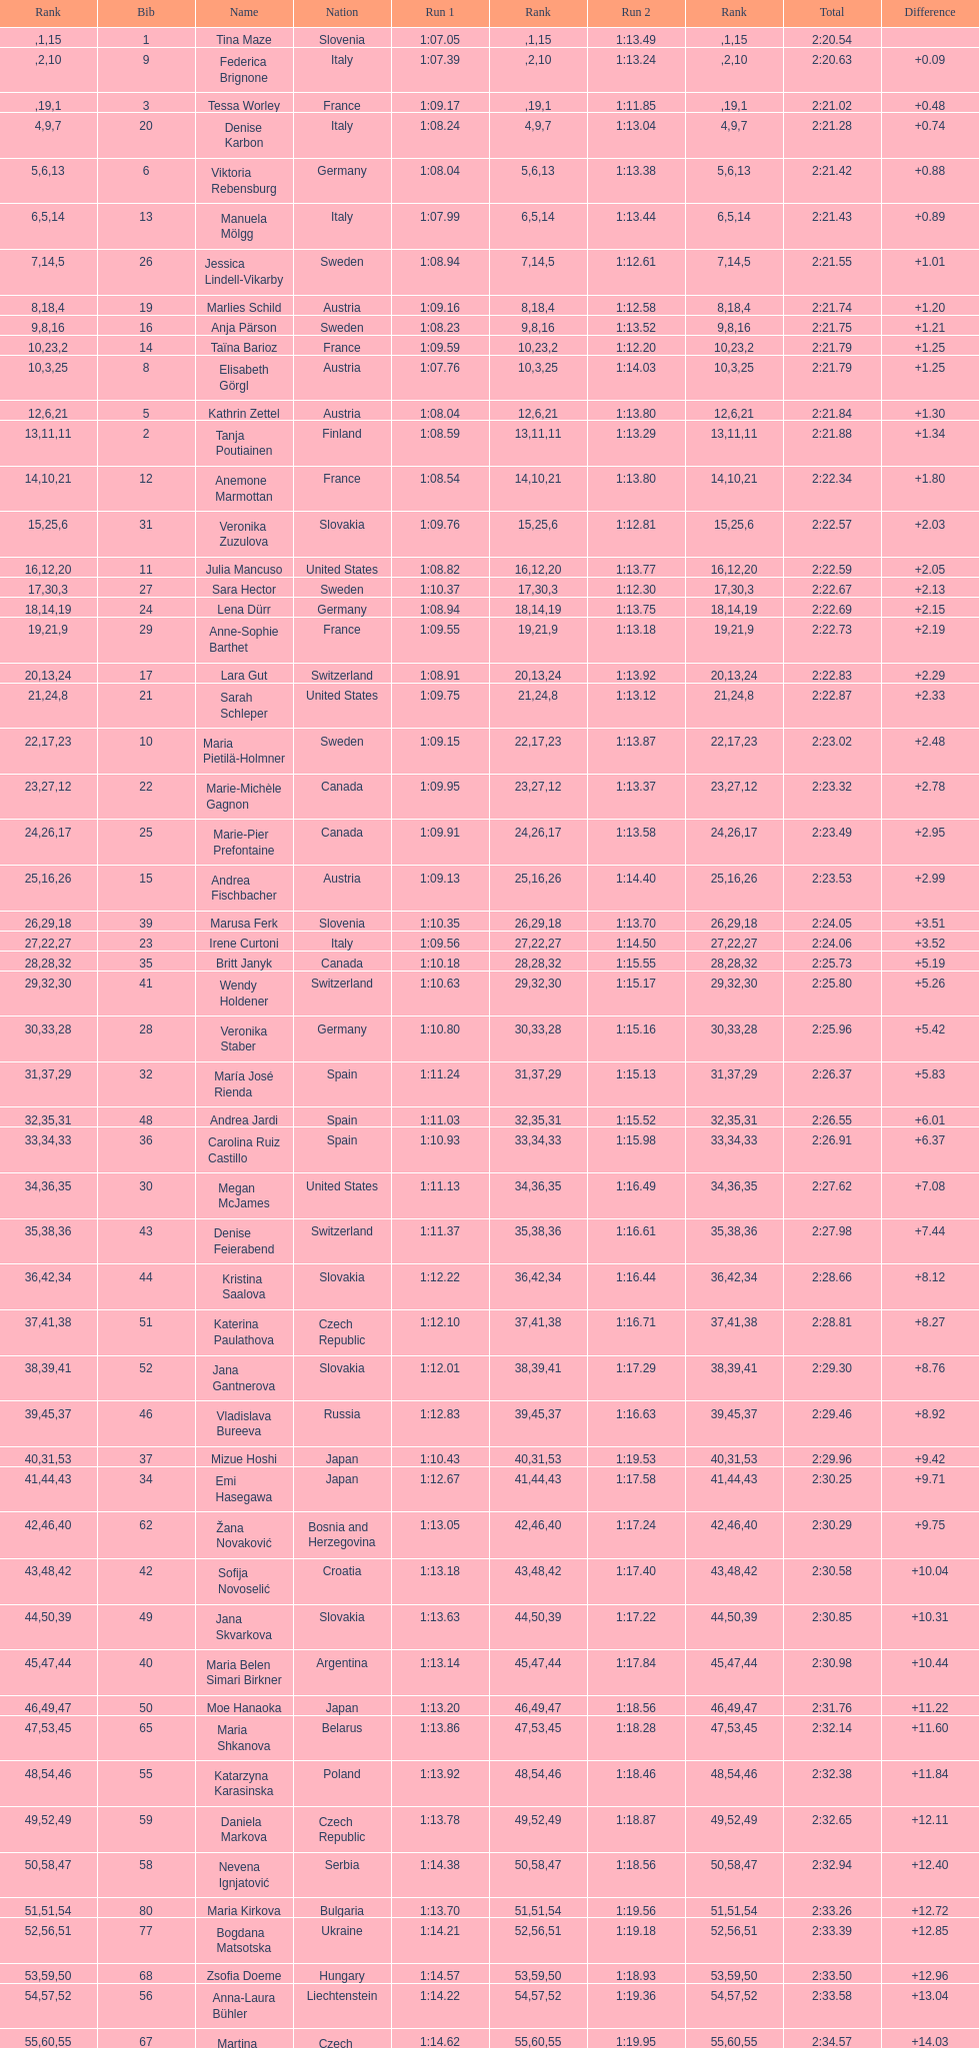Can you parse all the data within this table? {'header': ['Rank', 'Bib', 'Name', 'Nation', 'Run 1', 'Rank', 'Run 2', 'Rank', 'Total', 'Difference'], 'rows': [['', '1', 'Tina Maze', 'Slovenia', '1:07.05', '1', '1:13.49', '15', '2:20.54', ''], ['', '9', 'Federica Brignone', 'Italy', '1:07.39', '2', '1:13.24', '10', '2:20.63', '+0.09'], ['', '3', 'Tessa Worley', 'France', '1:09.17', '19', '1:11.85', '1', '2:21.02', '+0.48'], ['4', '20', 'Denise Karbon', 'Italy', '1:08.24', '9', '1:13.04', '7', '2:21.28', '+0.74'], ['5', '6', 'Viktoria Rebensburg', 'Germany', '1:08.04', '6', '1:13.38', '13', '2:21.42', '+0.88'], ['6', '13', 'Manuela Mölgg', 'Italy', '1:07.99', '5', '1:13.44', '14', '2:21.43', '+0.89'], ['7', '26', 'Jessica Lindell-Vikarby', 'Sweden', '1:08.94', '14', '1:12.61', '5', '2:21.55', '+1.01'], ['8', '19', 'Marlies Schild', 'Austria', '1:09.16', '18', '1:12.58', '4', '2:21.74', '+1.20'], ['9', '16', 'Anja Pärson', 'Sweden', '1:08.23', '8', '1:13.52', '16', '2:21.75', '+1.21'], ['10', '14', 'Taïna Barioz', 'France', '1:09.59', '23', '1:12.20', '2', '2:21.79', '+1.25'], ['10', '8', 'Elisabeth Görgl', 'Austria', '1:07.76', '3', '1:14.03', '25', '2:21.79', '+1.25'], ['12', '5', 'Kathrin Zettel', 'Austria', '1:08.04', '6', '1:13.80', '21', '2:21.84', '+1.30'], ['13', '2', 'Tanja Poutiainen', 'Finland', '1:08.59', '11', '1:13.29', '11', '2:21.88', '+1.34'], ['14', '12', 'Anemone Marmottan', 'France', '1:08.54', '10', '1:13.80', '21', '2:22.34', '+1.80'], ['15', '31', 'Veronika Zuzulova', 'Slovakia', '1:09.76', '25', '1:12.81', '6', '2:22.57', '+2.03'], ['16', '11', 'Julia Mancuso', 'United States', '1:08.82', '12', '1:13.77', '20', '2:22.59', '+2.05'], ['17', '27', 'Sara Hector', 'Sweden', '1:10.37', '30', '1:12.30', '3', '2:22.67', '+2.13'], ['18', '24', 'Lena Dürr', 'Germany', '1:08.94', '14', '1:13.75', '19', '2:22.69', '+2.15'], ['19', '29', 'Anne-Sophie Barthet', 'France', '1:09.55', '21', '1:13.18', '9', '2:22.73', '+2.19'], ['20', '17', 'Lara Gut', 'Switzerland', '1:08.91', '13', '1:13.92', '24', '2:22.83', '+2.29'], ['21', '21', 'Sarah Schleper', 'United States', '1:09.75', '24', '1:13.12', '8', '2:22.87', '+2.33'], ['22', '10', 'Maria Pietilä-Holmner', 'Sweden', '1:09.15', '17', '1:13.87', '23', '2:23.02', '+2.48'], ['23', '22', 'Marie-Michèle Gagnon', 'Canada', '1:09.95', '27', '1:13.37', '12', '2:23.32', '+2.78'], ['24', '25', 'Marie-Pier Prefontaine', 'Canada', '1:09.91', '26', '1:13.58', '17', '2:23.49', '+2.95'], ['25', '15', 'Andrea Fischbacher', 'Austria', '1:09.13', '16', '1:14.40', '26', '2:23.53', '+2.99'], ['26', '39', 'Marusa Ferk', 'Slovenia', '1:10.35', '29', '1:13.70', '18', '2:24.05', '+3.51'], ['27', '23', 'Irene Curtoni', 'Italy', '1:09.56', '22', '1:14.50', '27', '2:24.06', '+3.52'], ['28', '35', 'Britt Janyk', 'Canada', '1:10.18', '28', '1:15.55', '32', '2:25.73', '+5.19'], ['29', '41', 'Wendy Holdener', 'Switzerland', '1:10.63', '32', '1:15.17', '30', '2:25.80', '+5.26'], ['30', '28', 'Veronika Staber', 'Germany', '1:10.80', '33', '1:15.16', '28', '2:25.96', '+5.42'], ['31', '32', 'María José Rienda', 'Spain', '1:11.24', '37', '1:15.13', '29', '2:26.37', '+5.83'], ['32', '48', 'Andrea Jardi', 'Spain', '1:11.03', '35', '1:15.52', '31', '2:26.55', '+6.01'], ['33', '36', 'Carolina Ruiz Castillo', 'Spain', '1:10.93', '34', '1:15.98', '33', '2:26.91', '+6.37'], ['34', '30', 'Megan McJames', 'United States', '1:11.13', '36', '1:16.49', '35', '2:27.62', '+7.08'], ['35', '43', 'Denise Feierabend', 'Switzerland', '1:11.37', '38', '1:16.61', '36', '2:27.98', '+7.44'], ['36', '44', 'Kristina Saalova', 'Slovakia', '1:12.22', '42', '1:16.44', '34', '2:28.66', '+8.12'], ['37', '51', 'Katerina Paulathova', 'Czech Republic', '1:12.10', '41', '1:16.71', '38', '2:28.81', '+8.27'], ['38', '52', 'Jana Gantnerova', 'Slovakia', '1:12.01', '39', '1:17.29', '41', '2:29.30', '+8.76'], ['39', '46', 'Vladislava Bureeva', 'Russia', '1:12.83', '45', '1:16.63', '37', '2:29.46', '+8.92'], ['40', '37', 'Mizue Hoshi', 'Japan', '1:10.43', '31', '1:19.53', '53', '2:29.96', '+9.42'], ['41', '34', 'Emi Hasegawa', 'Japan', '1:12.67', '44', '1:17.58', '43', '2:30.25', '+9.71'], ['42', '62', 'Žana Novaković', 'Bosnia and Herzegovina', '1:13.05', '46', '1:17.24', '40', '2:30.29', '+9.75'], ['43', '42', 'Sofija Novoselić', 'Croatia', '1:13.18', '48', '1:17.40', '42', '2:30.58', '+10.04'], ['44', '49', 'Jana Skvarkova', 'Slovakia', '1:13.63', '50', '1:17.22', '39', '2:30.85', '+10.31'], ['45', '40', 'Maria Belen Simari Birkner', 'Argentina', '1:13.14', '47', '1:17.84', '44', '2:30.98', '+10.44'], ['46', '50', 'Moe Hanaoka', 'Japan', '1:13.20', '49', '1:18.56', '47', '2:31.76', '+11.22'], ['47', '65', 'Maria Shkanova', 'Belarus', '1:13.86', '53', '1:18.28', '45', '2:32.14', '+11.60'], ['48', '55', 'Katarzyna Karasinska', 'Poland', '1:13.92', '54', '1:18.46', '46', '2:32.38', '+11.84'], ['49', '59', 'Daniela Markova', 'Czech Republic', '1:13.78', '52', '1:18.87', '49', '2:32.65', '+12.11'], ['50', '58', 'Nevena Ignjatović', 'Serbia', '1:14.38', '58', '1:18.56', '47', '2:32.94', '+12.40'], ['51', '80', 'Maria Kirkova', 'Bulgaria', '1:13.70', '51', '1:19.56', '54', '2:33.26', '+12.72'], ['52', '77', 'Bogdana Matsotska', 'Ukraine', '1:14.21', '56', '1:19.18', '51', '2:33.39', '+12.85'], ['53', '68', 'Zsofia Doeme', 'Hungary', '1:14.57', '59', '1:18.93', '50', '2:33.50', '+12.96'], ['54', '56', 'Anna-Laura Bühler', 'Liechtenstein', '1:14.22', '57', '1:19.36', '52', '2:33.58', '+13.04'], ['55', '67', 'Martina Dubovska', 'Czech Republic', '1:14.62', '60', '1:19.95', '55', '2:34.57', '+14.03'], ['', '7', 'Kathrin Hölzl', 'Germany', '1:09.41', '20', 'DNS', '', '', ''], ['', '4', 'Maria Riesch', 'Germany', '1:07.86', '4', 'DNF', '', '', ''], ['', '38', 'Rebecca Bühler', 'Liechtenstein', '1:12.03', '40', 'DNF', '', '', ''], ['', '47', 'Vanessa Schädler', 'Liechtenstein', '1:12.47', '43', 'DNF', '', '', ''], ['', '69', 'Iris Gudmundsdottir', 'Iceland', '1:13.93', '55', 'DNF', '', '', ''], ['', '45', 'Tea Palić', 'Croatia', '1:14.73', '61', 'DNQ', '', '', ''], ['', '74', 'Macarena Simari Birkner', 'Argentina', '1:15.18', '62', 'DNQ', '', '', ''], ['', '72', 'Lavinia Chrystal', 'Australia', '1:15.35', '63', 'DNQ', '', '', ''], ['', '81', 'Lelde Gasuna', 'Latvia', '1:15.37', '64', 'DNQ', '', '', ''], ['', '64', 'Aleksandra Klus', 'Poland', '1:15.41', '65', 'DNQ', '', '', ''], ['', '78', 'Nino Tsiklauri', 'Georgia', '1:15.54', '66', 'DNQ', '', '', ''], ['', '66', 'Sarah Jarvis', 'New Zealand', '1:15.94', '67', 'DNQ', '', '', ''], ['', '61', 'Anna Berecz', 'Hungary', '1:15.95', '68', 'DNQ', '', '', ''], ['', '83', 'Sandra-Elena Narea', 'Romania', '1:16.67', '69', 'DNQ', '', '', ''], ['', '85', 'Iulia Petruta Craciun', 'Romania', '1:16.80', '70', 'DNQ', '', '', ''], ['', '82', 'Isabel van Buynder', 'Belgium', '1:17.06', '71', 'DNQ', '', '', ''], ['', '97', 'Liene Fimbauere', 'Latvia', '1:17.83', '72', 'DNQ', '', '', ''], ['', '86', 'Kristina Krone', 'Puerto Rico', '1:17.93', '73', 'DNQ', '', '', ''], ['', '88', 'Nicole Valcareggi', 'Greece', '1:18.19', '74', 'DNQ', '', '', ''], ['', '100', 'Sophie Fjellvang-Sølling', 'Denmark', '1:18.37', '75', 'DNQ', '', '', ''], ['', '95', 'Ornella Oettl Reyes', 'Peru', '1:18.61', '76', 'DNQ', '', '', ''], ['', '73', 'Xia Lina', 'China', '1:19.12', '77', 'DNQ', '', '', ''], ['', '94', 'Kseniya Grigoreva', 'Uzbekistan', '1:19.16', '78', 'DNQ', '', '', ''], ['', '87', 'Tugba Dasdemir', 'Turkey', '1:21.50', '79', 'DNQ', '', '', ''], ['', '92', 'Malene Madsen', 'Denmark', '1:22.25', '80', 'DNQ', '', '', ''], ['', '84', 'Liu Yang', 'China', '1:22.80', '81', 'DNQ', '', '', ''], ['', '91', 'Yom Hirshfeld', 'Israel', '1:22.87', '82', 'DNQ', '', '', ''], ['', '75', 'Salome Bancora', 'Argentina', '1:23.08', '83', 'DNQ', '', '', ''], ['', '93', 'Ronnie Kiek-Gedalyahu', 'Israel', '1:23.38', '84', 'DNQ', '', '', ''], ['', '96', 'Chiara Marano', 'Brazil', '1:24.16', '85', 'DNQ', '', '', ''], ['', '113', 'Anne Libak Nielsen', 'Denmark', '1:25.08', '86', 'DNQ', '', '', ''], ['', '105', 'Donata Hellner', 'Hungary', '1:26.97', '87', 'DNQ', '', '', ''], ['', '102', 'Liu Yu', 'China', '1:27.03', '88', 'DNQ', '', '', ''], ['', '109', 'Lida Zvoznikova', 'Kyrgyzstan', '1:27.17', '89', 'DNQ', '', '', ''], ['', '103', 'Szelina Hellner', 'Hungary', '1:27.27', '90', 'DNQ', '', '', ''], ['', '114', 'Irina Volkova', 'Kyrgyzstan', '1:29.73', '91', 'DNQ', '', '', ''], ['', '106', 'Svetlana Baranova', 'Uzbekistan', '1:30.62', '92', 'DNQ', '', '', ''], ['', '108', 'Tatjana Baranova', 'Uzbekistan', '1:31.81', '93', 'DNQ', '', '', ''], ['', '110', 'Fatemeh Kiadarbandsari', 'Iran', '1:32.16', '94', 'DNQ', '', '', ''], ['', '107', 'Ziba Kalhor', 'Iran', '1:32.64', '95', 'DNQ', '', '', ''], ['', '104', 'Paraskevi Mavridou', 'Greece', '1:32.83', '96', 'DNQ', '', '', ''], ['', '99', 'Marjan Kalhor', 'Iran', '1:34.94', '97', 'DNQ', '', '', ''], ['', '112', 'Mitra Kalhor', 'Iran', '1:37.93', '98', 'DNQ', '', '', ''], ['', '115', 'Laura Bauer', 'South Africa', '1:42.19', '99', 'DNQ', '', '', ''], ['', '111', 'Sarah Ekmekejian', 'Lebanon', '1:42.22', '100', 'DNQ', '', '', ''], ['', '18', 'Fabienne Suter', 'Switzerland', 'DNS', '', '', '', '', ''], ['', '98', 'Maja Klepić', 'Bosnia and Herzegovina', 'DNS', '', '', '', '', ''], ['', '33', 'Agniezska Gasienica Daniel', 'Poland', 'DNF', '', '', '', '', ''], ['', '53', 'Karolina Chrapek', 'Poland', 'DNF', '', '', '', '', ''], ['', '54', 'Mireia Gutierrez', 'Andorra', 'DNF', '', '', '', '', ''], ['', '57', 'Brittany Phelan', 'Canada', 'DNF', '', '', '', '', ''], ['', '60', 'Tereza Kmochova', 'Czech Republic', 'DNF', '', '', '', '', ''], ['', '63', 'Michelle van Herwerden', 'Netherlands', 'DNF', '', '', '', '', ''], ['', '70', 'Maya Harrisson', 'Brazil', 'DNF', '', '', '', '', ''], ['', '71', 'Elizabeth Pilat', 'Australia', 'DNF', '', '', '', '', ''], ['', '76', 'Katrin Kristjansdottir', 'Iceland', 'DNF', '', '', '', '', ''], ['', '79', 'Julietta Quiroga', 'Argentina', 'DNF', '', '', '', '', ''], ['', '89', 'Evija Benhena', 'Latvia', 'DNF', '', '', '', '', ''], ['', '90', 'Qin Xiyue', 'China', 'DNF', '', '', '', '', ''], ['', '101', 'Sophia Ralli', 'Greece', 'DNF', '', '', '', '', ''], ['', '116', 'Siranush Maghakyan', 'Armenia', 'DNF', '', '', '', '', '']]} In the top fifteen, what was the quantity of swedes? 2. 